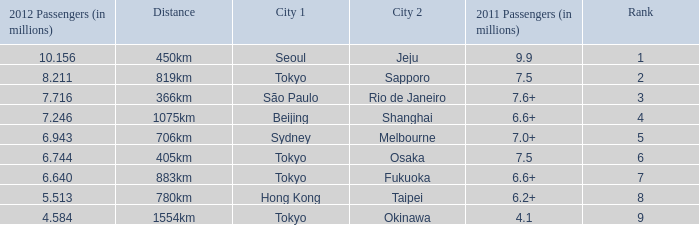How many passengers (in millions) flew from Seoul in 2012? 10.156. 